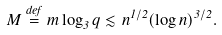Convert formula to latex. <formula><loc_0><loc_0><loc_500><loc_500>M \stackrel { d e f } { = } m \log _ { 3 } q \lesssim n ^ { 1 / 2 } ( \log n ) ^ { 3 / 2 } .</formula> 